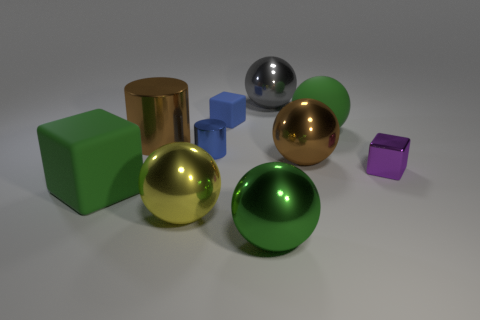Subtract all large green rubber blocks. How many blocks are left? 2 Subtract all blue blocks. How many blocks are left? 2 Subtract all yellow spheres. Subtract all matte blocks. How many objects are left? 7 Add 4 small purple shiny cubes. How many small purple shiny cubes are left? 5 Add 9 gray cylinders. How many gray cylinders exist? 9 Subtract 0 blue balls. How many objects are left? 10 Subtract all cubes. How many objects are left? 7 Subtract 1 cylinders. How many cylinders are left? 1 Subtract all yellow blocks. Subtract all purple cylinders. How many blocks are left? 3 Subtract all red cubes. How many yellow balls are left? 1 